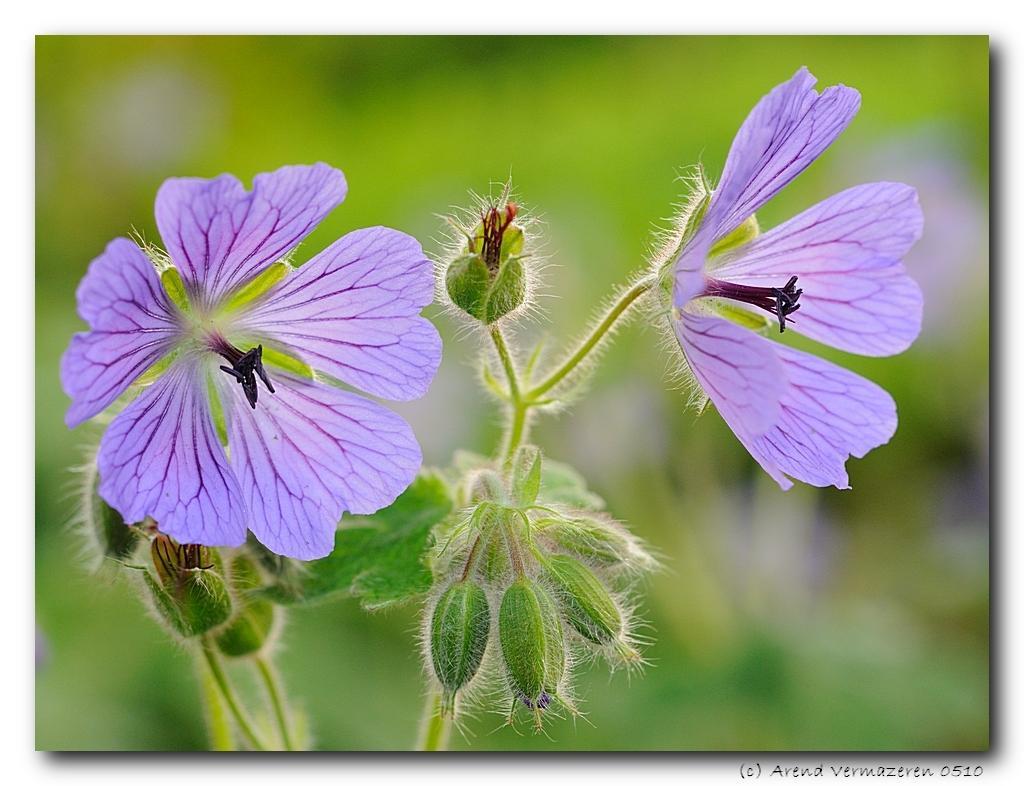Could you give a brief overview of what you see in this image? This is an edited image. I can see a plant with flowers and buds. There is a blurred background. At the bottom right corner of the image, I can see a watermark. 